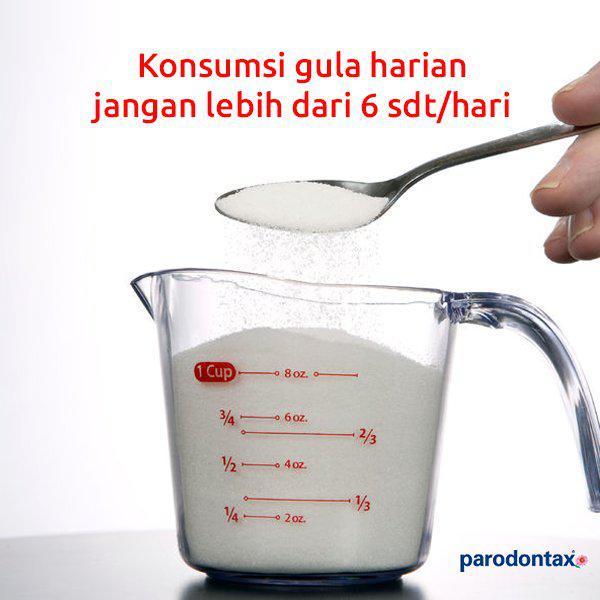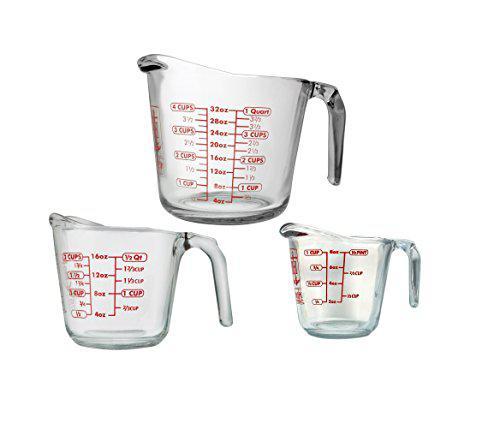The first image is the image on the left, the second image is the image on the right. Given the left and right images, does the statement "The left image shows a set of measuring spoons" hold true? Answer yes or no. No. The first image is the image on the left, the second image is the image on the right. Considering the images on both sides, is "A set of three clear measuring cups have red markings." valid? Answer yes or no. Yes. 